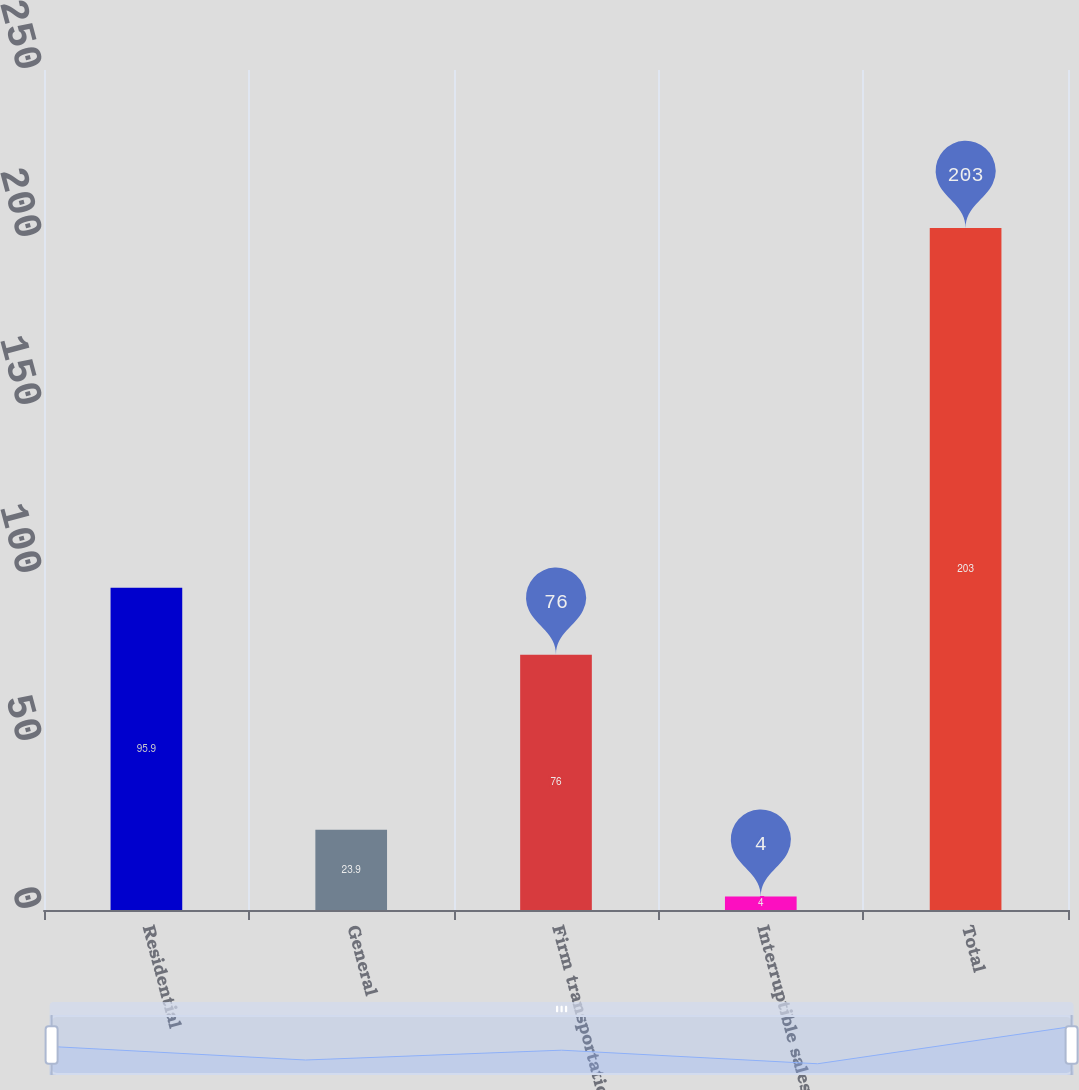Convert chart. <chart><loc_0><loc_0><loc_500><loc_500><bar_chart><fcel>Residential<fcel>General<fcel>Firm transportation<fcel>Interruptible sales<fcel>Total<nl><fcel>95.9<fcel>23.9<fcel>76<fcel>4<fcel>203<nl></chart> 